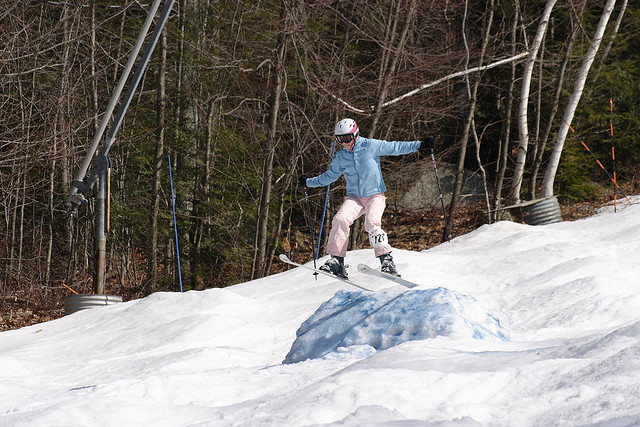<image>Is the temperature below 32 Fahrenheit? I am not sure if the temperature is below 32 Fahrenheit. Is the temperature below 32 Fahrenheit? I am not sure if the temperature is below 32 Fahrenheit. It can be both below or above 32 Fahrenheit. 